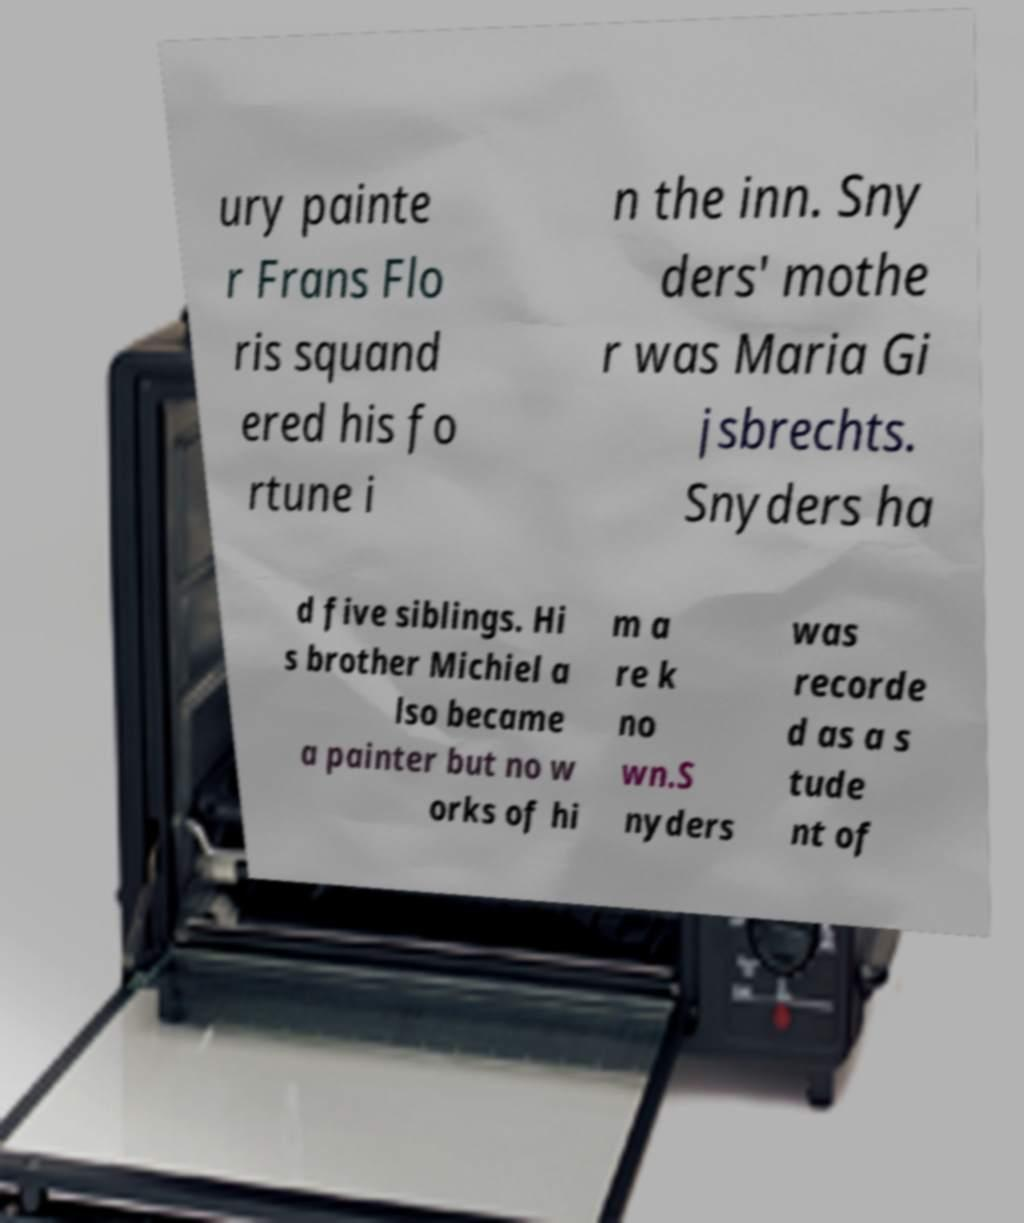I need the written content from this picture converted into text. Can you do that? ury painte r Frans Flo ris squand ered his fo rtune i n the inn. Sny ders' mothe r was Maria Gi jsbrechts. Snyders ha d five siblings. Hi s brother Michiel a lso became a painter but no w orks of hi m a re k no wn.S nyders was recorde d as a s tude nt of 